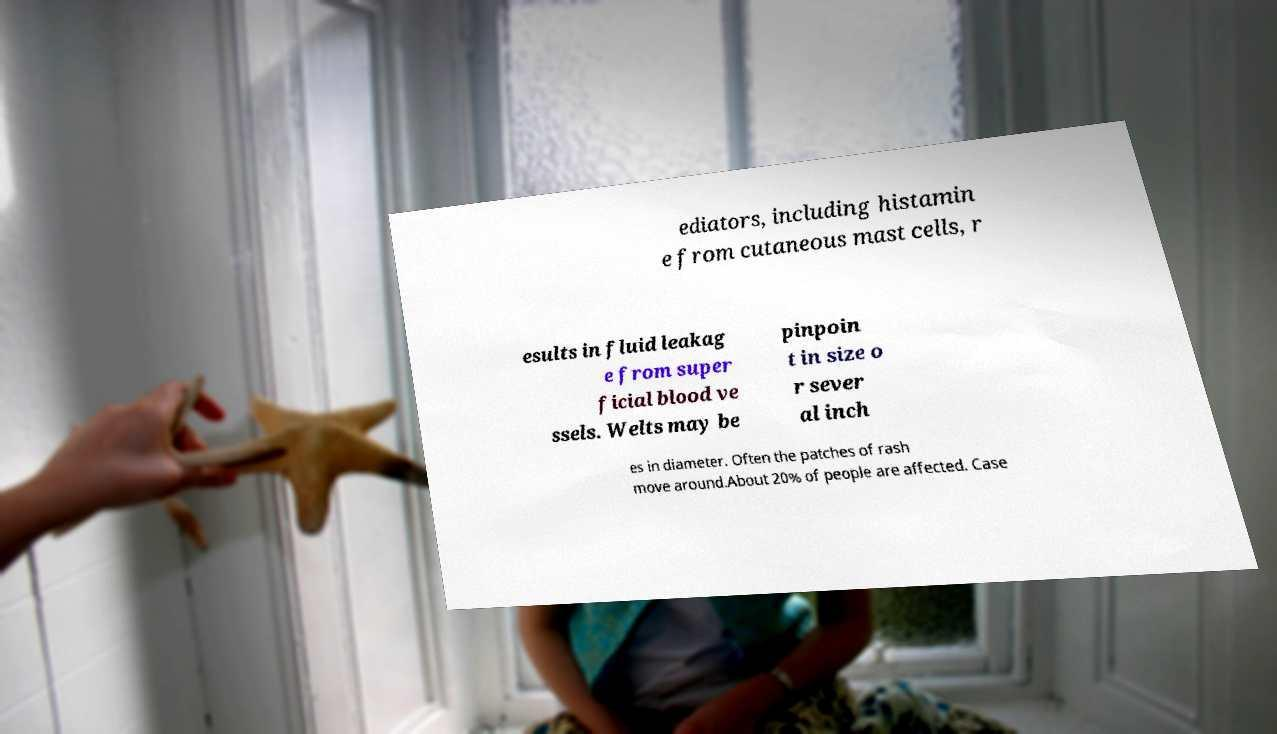Could you extract and type out the text from this image? ediators, including histamin e from cutaneous mast cells, r esults in fluid leakag e from super ficial blood ve ssels. Welts may be pinpoin t in size o r sever al inch es in diameter. Often the patches of rash move around.About 20% of people are affected. Case 